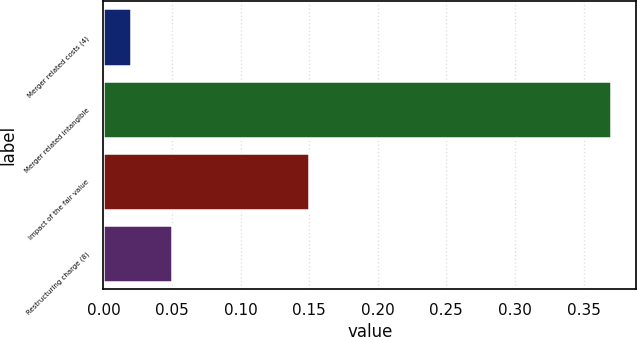<chart> <loc_0><loc_0><loc_500><loc_500><bar_chart><fcel>Merger related costs (4)<fcel>Merger related intangible<fcel>Impact of the fair value<fcel>Restructuring charge (8)<nl><fcel>0.02<fcel>0.37<fcel>0.15<fcel>0.05<nl></chart> 